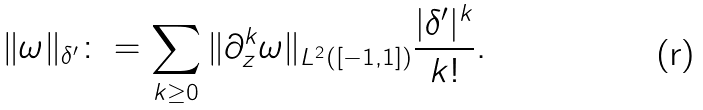Convert formula to latex. <formula><loc_0><loc_0><loc_500><loc_500>\| \omega \| _ { \delta ^ { \prime } } \colon = \sum _ { k \geq 0 } \| \partial _ { z } ^ { k } \omega \| _ { L ^ { 2 } ( [ - 1 , 1 ] ) } \frac { | \delta ^ { \prime } | ^ { k } } { k ! } .</formula> 